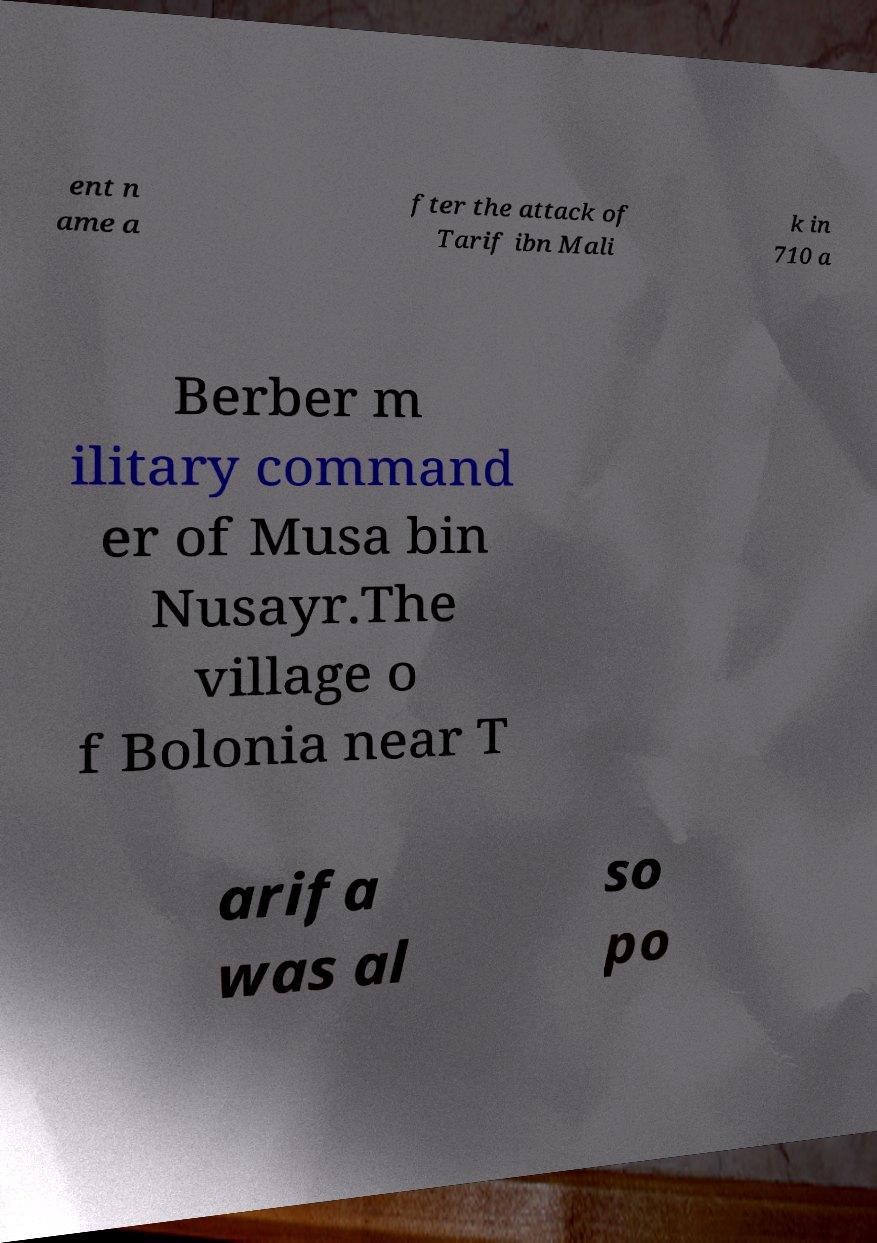I need the written content from this picture converted into text. Can you do that? ent n ame a fter the attack of Tarif ibn Mali k in 710 a Berber m ilitary command er of Musa bin Nusayr.The village o f Bolonia near T arifa was al so po 